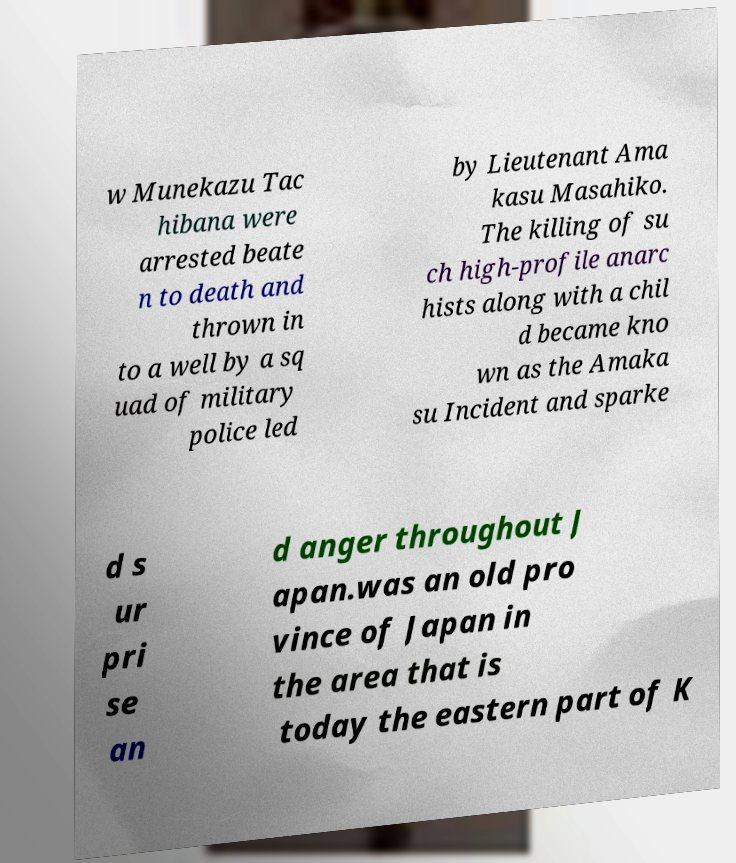Please read and relay the text visible in this image. What does it say? w Munekazu Tac hibana were arrested beate n to death and thrown in to a well by a sq uad of military police led by Lieutenant Ama kasu Masahiko. The killing of su ch high-profile anarc hists along with a chil d became kno wn as the Amaka su Incident and sparke d s ur pri se an d anger throughout J apan.was an old pro vince of Japan in the area that is today the eastern part of K 